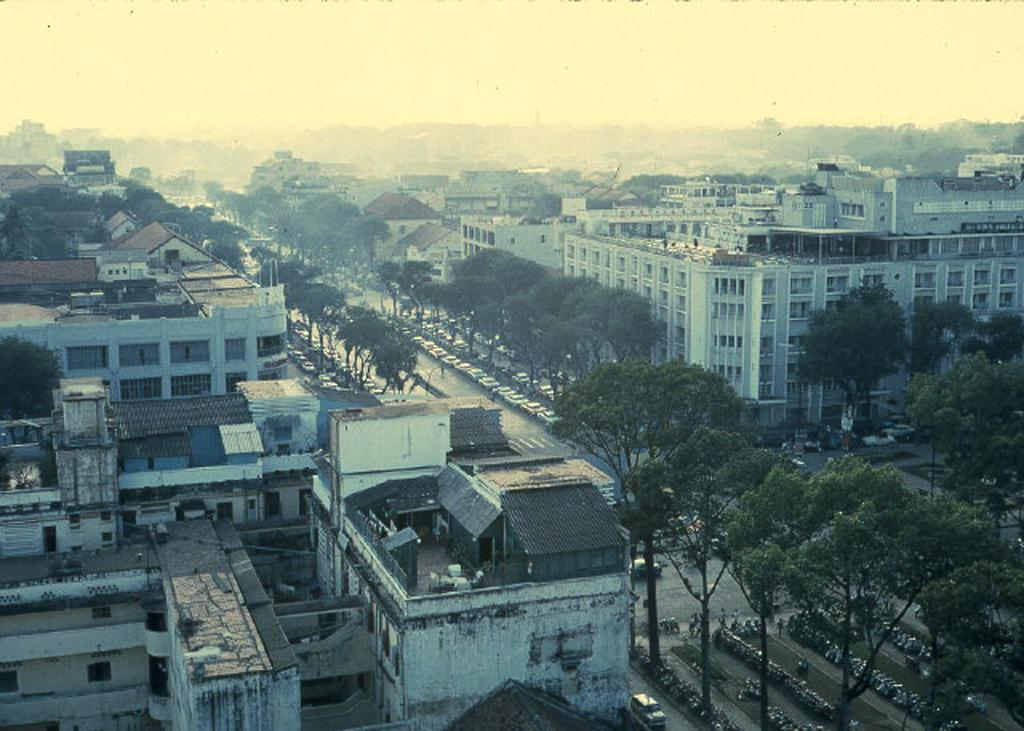What type of view is shown in the image? The image is a top view of a city. What structures can be seen in the image? There are buildings in the image. What natural elements are present in the image? There are trees in the image. What man-made objects can be seen in the image? There are vehicles in the image. Who or what is present on the roads in the image? People are present on the roads in the image. What type of plant is being used for acoustics in the image? There is no plant present in the image that is being used for acoustics. 